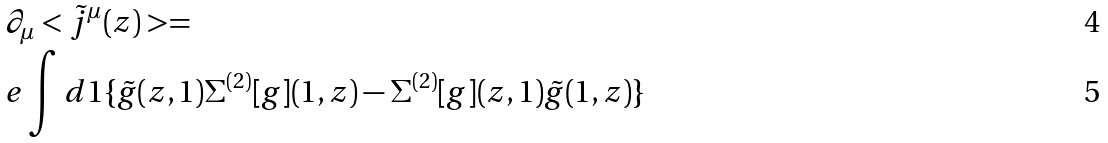Convert formula to latex. <formula><loc_0><loc_0><loc_500><loc_500>& \partial _ { \mu } < \tilde { j } ^ { \mu } ( z ) > = \\ & e \int d 1 \{ \tilde { g } ( z , 1 ) \Sigma ^ { ( 2 ) } [ g ] ( 1 , z ) - \Sigma ^ { ( 2 ) } [ g ] ( z , 1 ) \tilde { g } ( 1 , z ) \}</formula> 